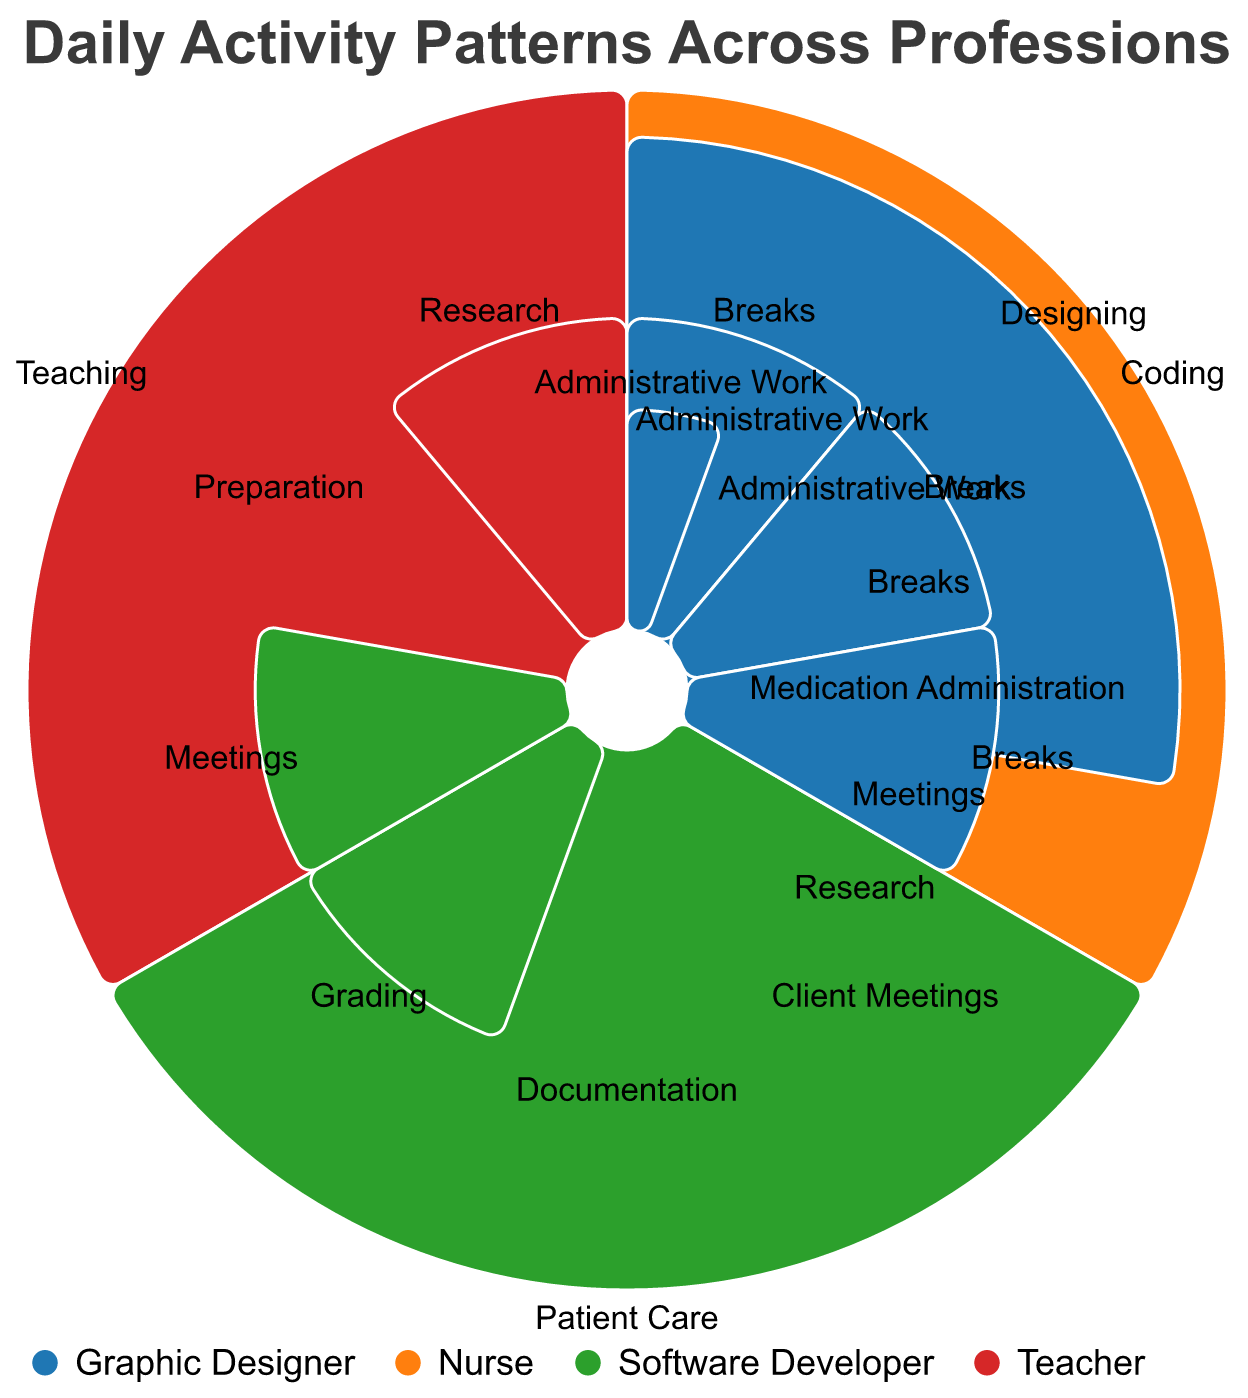Which profession has the most diversified activities? To determine which profession has the most diversified activities, count the distinct activities for each profession. The figure shows that Teachers, Nurses, Software Developers, and Graphic Designers all have 5 different activities each.
Answer: All have equal number of activities Which profession spends the most time on a single activity? By examining the chart and checking the duration of each activity, we see that Teachers, Nurses, and Software Developers each have an activity that spans 6 hours.
Answer: Teachers, Nurses, and Software Developers How many more hours do Teachers spend on Teaching compared to Preparation? Teachers spend 6 hours on Teaching and 2 hours on Preparation, so the difference is 6 - 2.
Answer: 4 hours Which activity is common to most professions? Look at the activities for all professions to find common ones. "Breaks" appears in all listed professions.
Answer: Breaks Who spends more hours on Meetings, Nurses or Software Developers? Compare the duration of Meetings for both professions. Nurses spend 1 hour, while Software Developers spend 2 hours.
Answer: Software Developers What's the average number of hours spent on Documentation by all professions combined? Only Nurses have Documentation. The average is simply the value for Nurses' Documentation.
Answer: 2 hours Do Graphic Designers spend more time on Designing or on Client Meetings and Research combined? Graphic Designers spend 5 hours on Designing. For Client Meetings and Research combined, sum the hours: 2 (Client Meetings) + 2 (Research) = 4 hours. Compare 5 hours with 4 hours.
Answer: Designing Between Software Developers and Graphic Designers, who takes longer breaks? Compare the Breaks activity duration for both professions. Both spend 2 hours on Breaks.
Answer: Both spend equal time What’s the total time spent on Administrative Work by all professions? Sum the hours spent on Administrative Work by all professions: Teacher (1), Nurse (0), Software Developer (1), Graphic Designer (1). Total = 1 + 0 + 1 + 1 = 3 hours.
Answer: 3 hours Which profession spends the least time on breaks? From the chart, observe the Breaks activity duration for each profession: Teachers (1 hour), Nurses (2 hours), Software Developers (2 hours), Graphic Designers (2 hours). Teachers spend the least time.
Answer: Teachers 